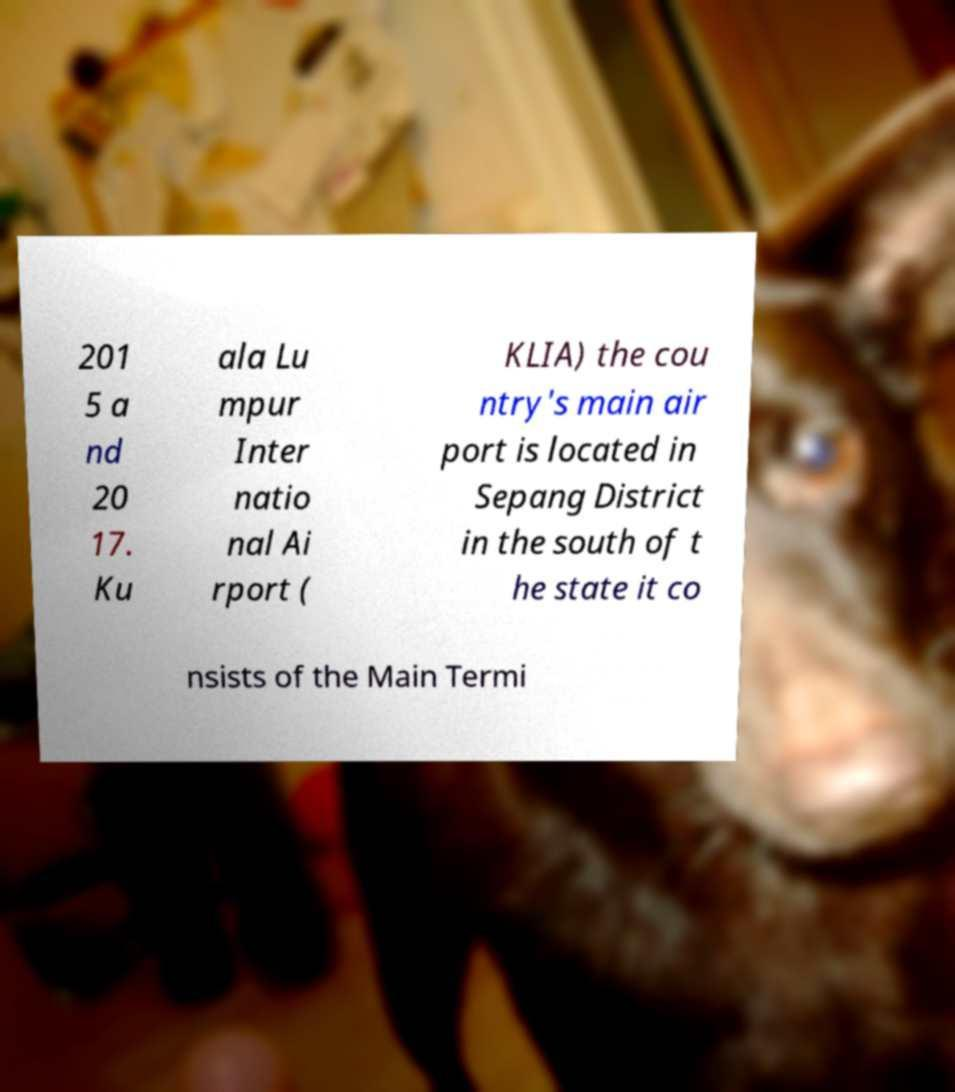Can you accurately transcribe the text from the provided image for me? 201 5 a nd 20 17. Ku ala Lu mpur Inter natio nal Ai rport ( KLIA) the cou ntry's main air port is located in Sepang District in the south of t he state it co nsists of the Main Termi 